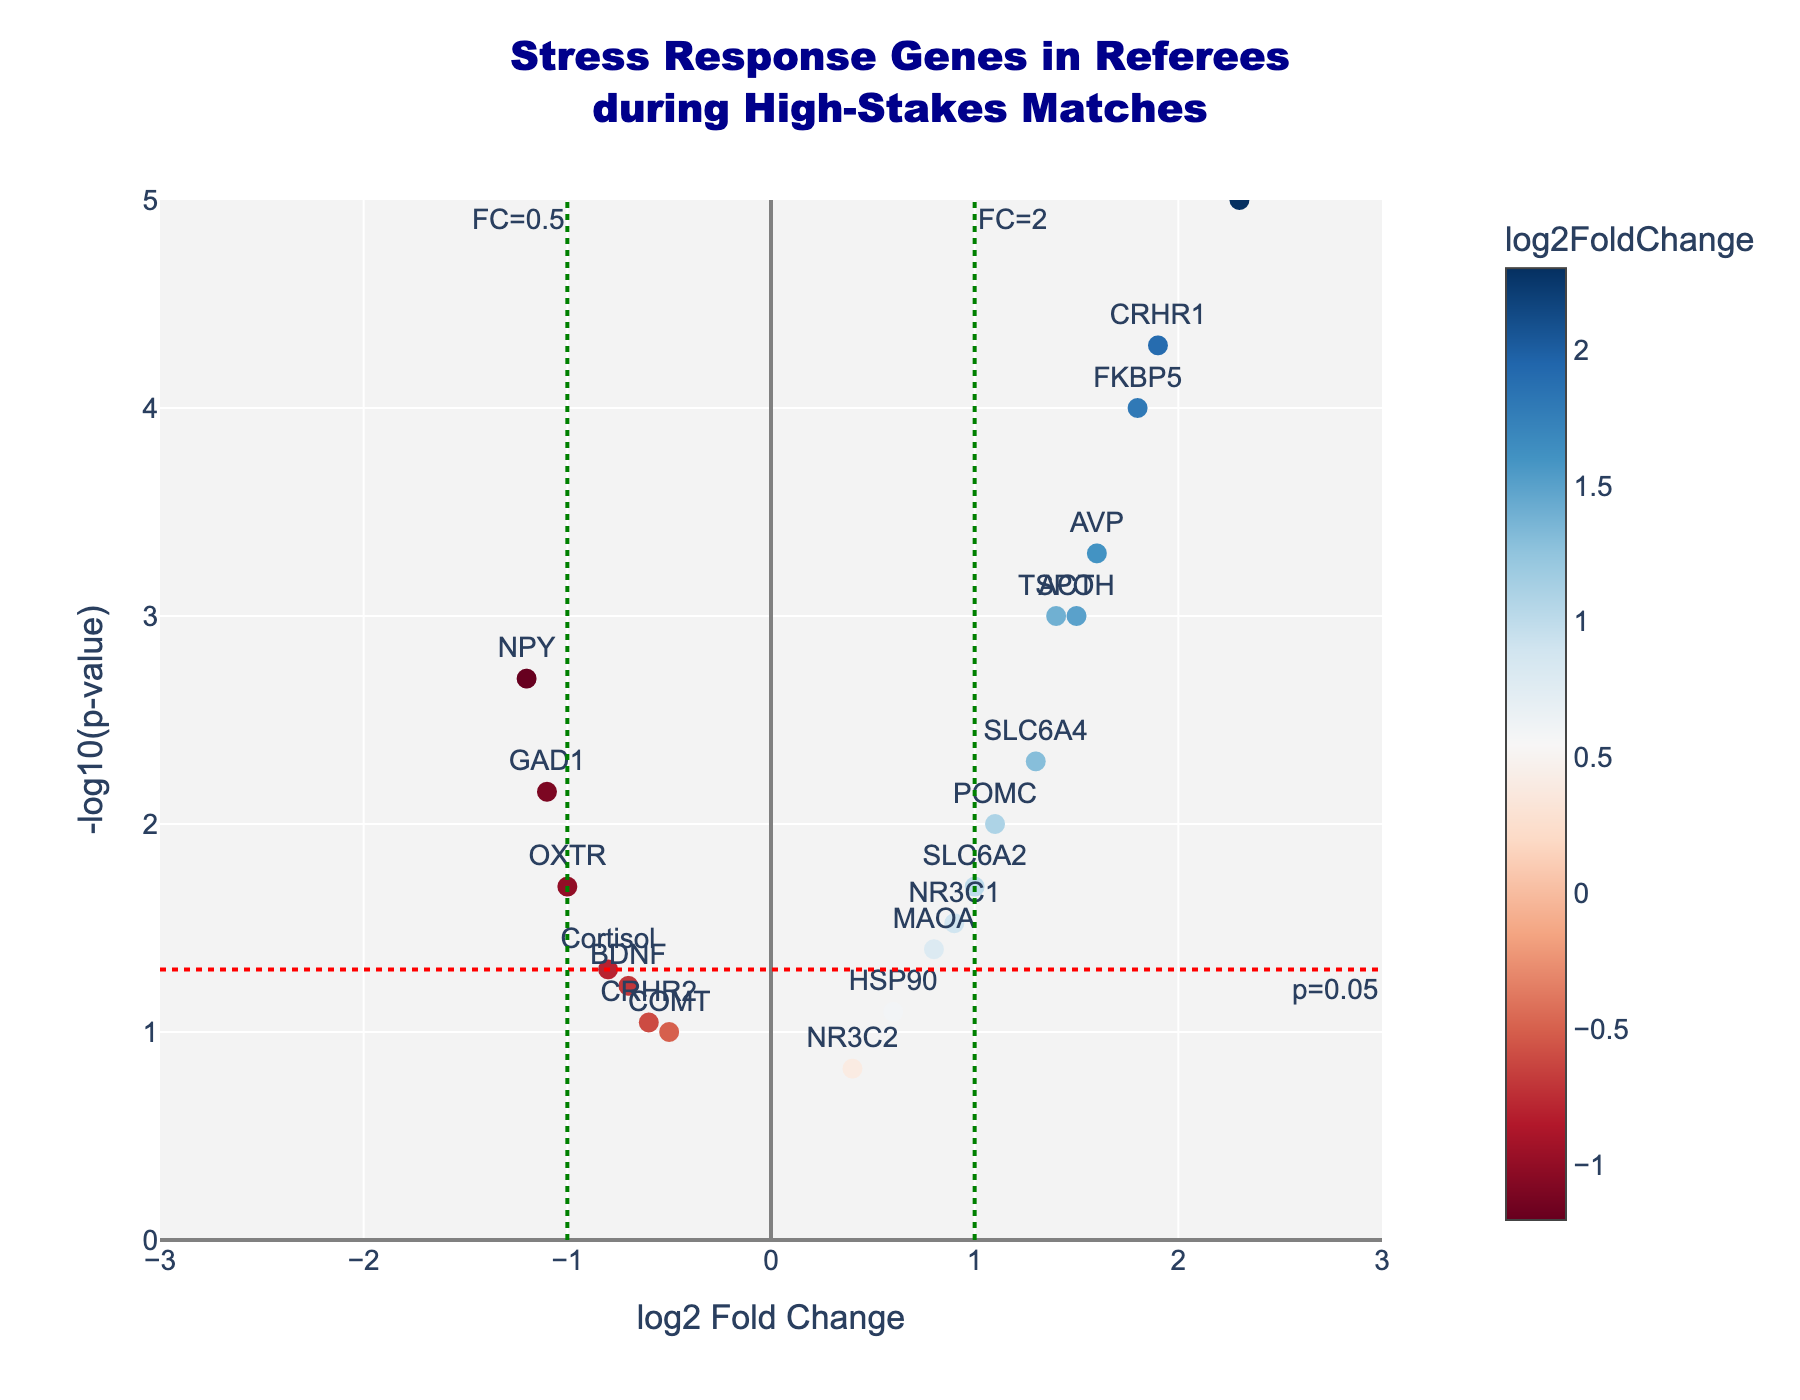What is the title of the plot? The title is located at the top center of the plot. Reading the text there will provide the title.
Answer: Stress Response Genes in Referees during High-Stakes Matches What do the x-axis and y-axis represent? The x-axis is labeled "log2 Fold Change," which indicates the fold change in gene expression on a log2 scale. The y-axis is labeled "-log10(p-value)," representing the negative logarithm (base 10) of the p-value, signifying the significance of the change.
Answer: log2 Fold Change and -log10(p-value) How many genes have a p-value less than 0.05? Genes with a p-value less than 0.05 will be plotted above the horizontal red dashed line which represents p=0.05. Count the number of data points above this line.
Answer: 14 Which gene has the highest log2 fold change? The gene with the highest log2 fold change will be the point farthest to the right on the x-axis. Check the label of this point.
Answer: CRH Which gene shows the lowest expression level? The gene with the lowest expression level will have the most negative log2 fold change. It will be the point farthest to the left on the x-axis. Check the label of this point.
Answer: NPY What is the significance threshold line for p-value on the plot, and why is it there? The horizontal red dashed line represents a -log10(p-value) of about 1.3, which corresponds to a p-value of 0.05. It indicates the threshold for statistical significance.
Answer: The threshold is p=0.05 How does the expression of the gene ACTH compare to that of NR3C2? Locate the points for ACTH and NR3C2, and compare their log2 fold change and -log10(p-value) values. ACTH has a log2 fold change of 1.5 and NR3C2 has a log2 fold change of 0.4.
Answer: ACTH has higher log2 fold change and more significant p-value than NR3C2 Which gene has almost no significant change in its expression level? Look for the gene close to both the origin on the x-axis (log2 fold change close to 0) and the origin on the y-axis (-log10(p-value) close to 0).
Answer: COMT Is the gene AVP up-regulated or down-regulated, and how significant is the change? Check the position of AVP on the x-axis; if it is on the right side of zero, it's up-regulated. Its position on the y-axis indicates the significance (-log10(p-value)). AVP has a log2 fold change of 1.6, placing it on the right side, and a -log10(p-value) of 3.3, indicating it is quite significant.
Answer: Up-regulated, highly significant Which two genes show down-regulated expression but with relatively low statistical significance (p > 0.05)? Find genes with negative log2 fold changes and -log10(p-value) below the red line. BDNF and CRHR2 meet these criteria.
Answer: BDNF and CRHR2 